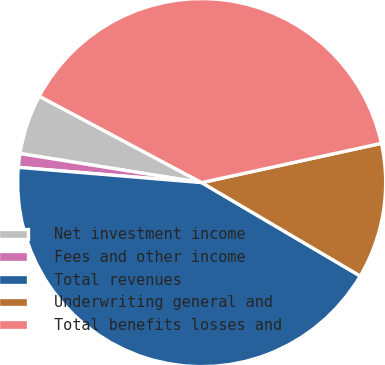Convert chart to OTSL. <chart><loc_0><loc_0><loc_500><loc_500><pie_chart><fcel>Net investment income<fcel>Fees and other income<fcel>Total revenues<fcel>Underwriting general and<fcel>Total benefits losses and<nl><fcel>5.26%<fcel>1.2%<fcel>42.85%<fcel>11.9%<fcel>38.79%<nl></chart> 